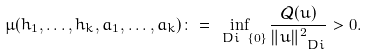<formula> <loc_0><loc_0><loc_500><loc_500>\mu ( h _ { 1 } , \dots , h _ { k } , a _ { 1 } , \dots , a _ { k } ) \colon = \inf _ { \ D i \ \{ 0 \} } \frac { { \mathcal { Q } } ( u ) } { \| u \| _ { \ D i } ^ { 2 } } > 0 .</formula> 